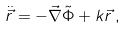Convert formula to latex. <formula><loc_0><loc_0><loc_500><loc_500>\ddot { \vec { r } } = - \vec { \nabla } \tilde { \Phi } + k \vec { r } \, ,</formula> 